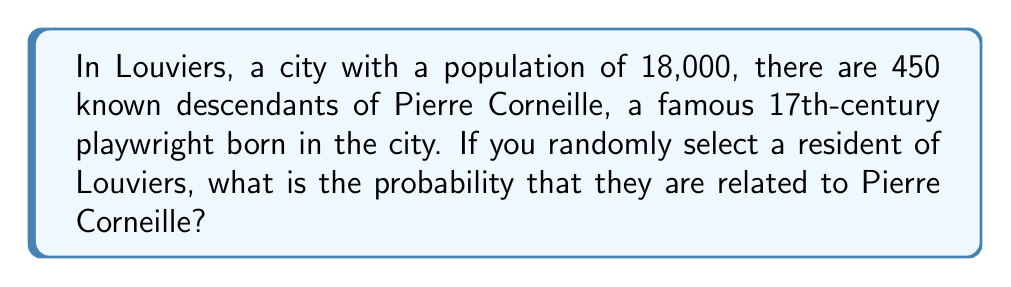Can you solve this math problem? To solve this problem, we need to follow these steps:

1. Identify the total population (sample space):
   $n(\text{Total population}) = 18,000$

2. Identify the number of favorable outcomes (descendants of Pierre Corneille):
   $n(\text{Descendants}) = 450$

3. Calculate the probability using the formula:
   $$P(\text{Related to Corneille}) = \frac{n(\text{Descendants})}{n(\text{Total population})}$$

4. Substitute the values:
   $$P(\text{Related to Corneille}) = \frac{450}{18,000}$$

5. Simplify the fraction:
   $$P(\text{Related to Corneille}) = \frac{1}{40} = 0.025$$

Therefore, the probability of randomly selecting a Louviers resident who is related to Pierre Corneille is $\frac{1}{40}$ or 0.025 or 2.5%.
Answer: $\frac{1}{40}$ 